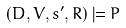<formula> <loc_0><loc_0><loc_500><loc_500>( D , V , s ^ { \prime } , R ) \models P</formula> 